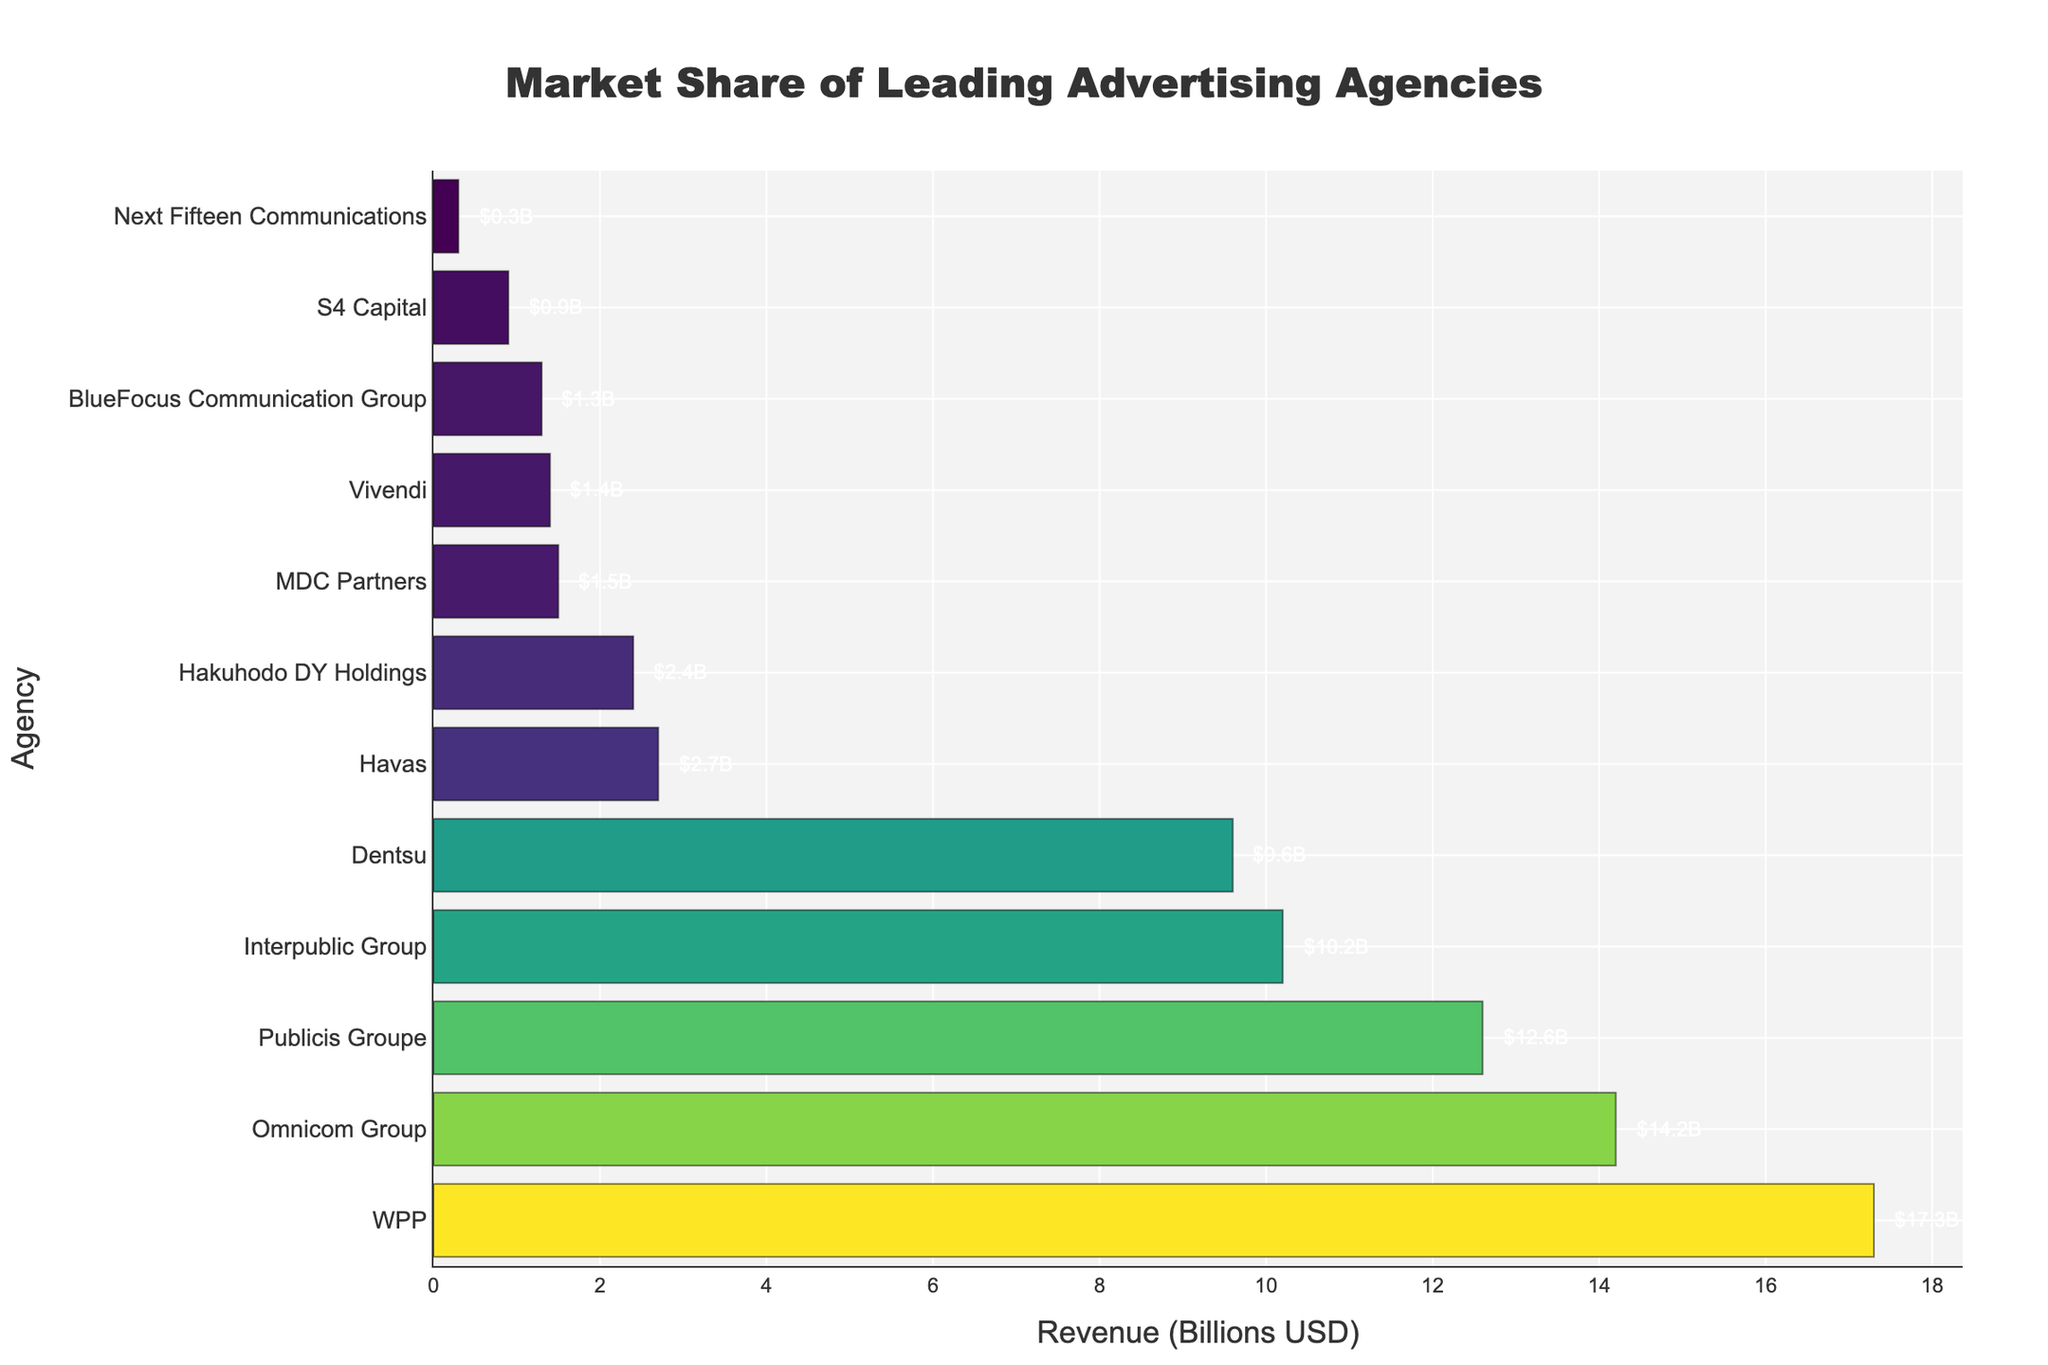What's the market share of the highest-revenue advertising agency? The figure shows the annual revenue of the top advertising agencies. By looking at the longest bar, we can see that WPP has the highest revenue, which is \$17.3 billion USD.
Answer: \$17.3 billion USD How much more revenue does Publicis Groupe generate compared to BlueFocus Communication Group? Publicis Groupe has a revenue of \$12.6 billion USD, and BlueFocus Communication Group has \$1.3 billion USD. Subtracting the two gives: 12.6 - 1.3 = 11.3.
Answer: \$11.3 billion USD Which agency has the least market share? The figure shows the market share of the agencies in descending order. The shortest bar belongs to Next Fifteen Communications, with a revenue of \$0.3 billion USD.
Answer: Next Fifteen Communications What's the combined revenue of the top three advertising agencies? The top three agencies by revenue are WPP (\$17.3 billion USD), Omnicom Group (\$14.2 billion USD), and Publicis Groupe (\$12.6 billion USD). Adding these together gives: 17.3 + 14.2 + 12.6 = 44.1.
Answer: \$44.1 billion USD Which agency has a revenue closest to \$10 billion USD? By looking at the figure, we can see that Interpublic Group has a revenue of \$10.2 billion USD, which is closest to \$10 billion USD.
Answer: Interpublic Group Does any agency have exactly half the revenue of WPP? WPP has a revenue of \$17.3 billion USD; half of this is 17.3 / 2 = 8.65. Among the agencies, none have this specific revenue value.
Answer: No Compare the market share of Omnicom Group and Dentsu. Which is higher and by how much? Omnicom Group has a revenue of \$14.2 billion USD, and Dentsu has \$9.6 billion USD. The difference is: 14.2 - 9.6 = 4.6. Omnicom Group has a higher market share.
Answer: Omnicom Group by \$4.6 billion USD List all agencies with revenue greater than \$10 billion USD. By inspecting the figure, the agencies with revenue greater than \$10 billion USD are WPP (\$17.3 billion USD), Omnicom Group (\$14.2 billion USD), Publicis Groupe (\$12.6 billion USD), and Interpublic Group (\$10.2 billion USD).
Answer: WPP, Omnicom Group, Publicis Groupe, Interpublic Group How does the revenue of Havas compare to that of Vivendi? Havas has a revenue of \$2.7 billion USD, and Vivendi has \$1.4 billion USD. Since 2.7 is greater than 1.4, Havas has a higher revenue.
Answer: Havas has higher revenue What's the average revenue of all listed agencies? To find the average, sum the revenues: 17.3 + 14.2 + 12.6 + 10.2 + 9.6 + 2.7 + 2.4 + 1.5 + 1.4 + 1.3 + 0.9 + 0.3 = 74.4. Then, divide by the number of agencies: 74.4 / 12 ≈ 6.2.
Answer: \$6.2 billion USD 